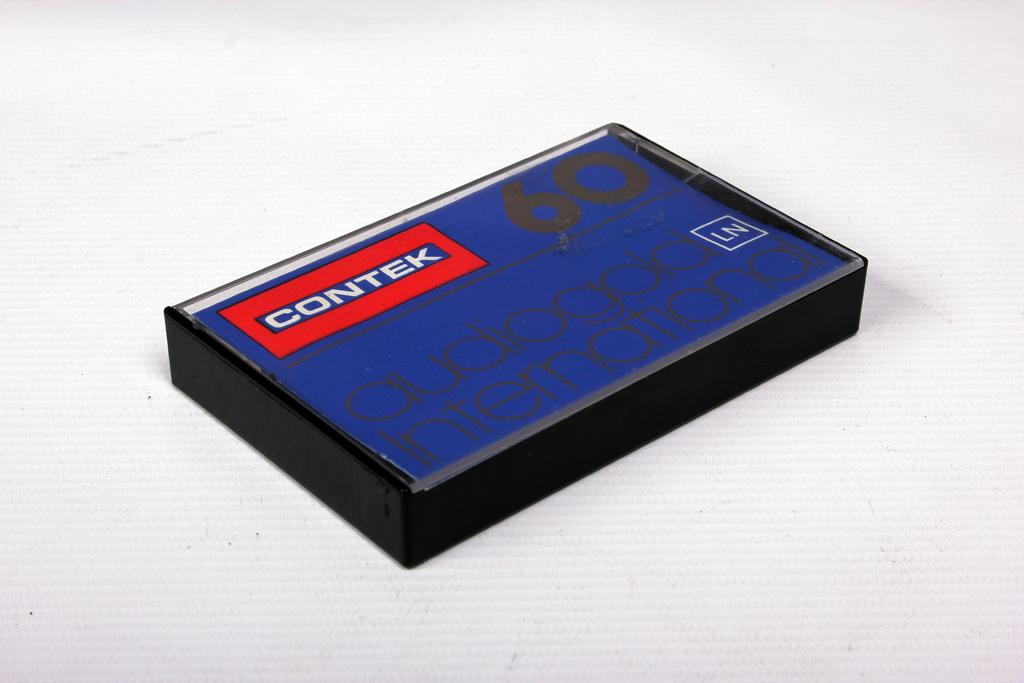Provide a one-sentence caption for the provided image. a blue cassett tape with black writing by contek. 